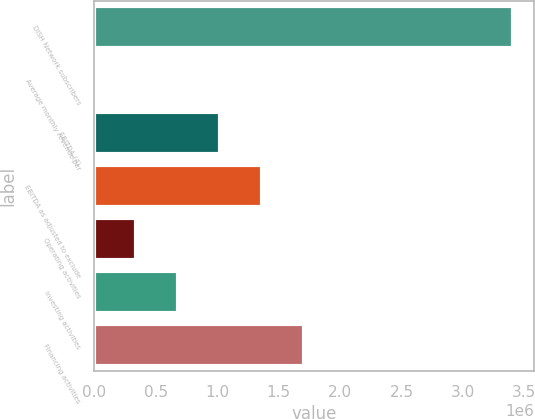Convert chart. <chart><loc_0><loc_0><loc_500><loc_500><bar_chart><fcel>DISH Network subscribers<fcel>Average monthly revenue per<fcel>EBITDA (4)<fcel>EBITDA as adjusted to exclude<fcel>Operating activities<fcel>Investing activities<fcel>Financing activities<nl><fcel>3.41e+06<fcel>42.71<fcel>1.02303e+06<fcel>1.36403e+06<fcel>341038<fcel>682034<fcel>1.70502e+06<nl></chart> 